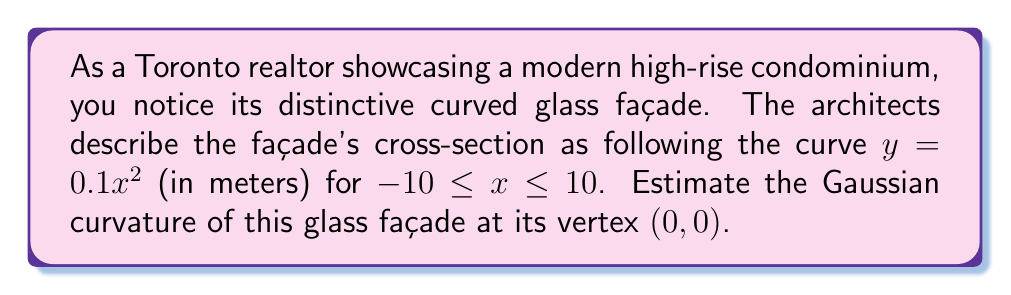Give your solution to this math problem. To estimate the Gaussian curvature of the curved glass façade, we'll follow these steps:

1) The curve is given by $y = 0.1x^2$ in the xz-plane. We can represent this as a surface by extending it along the y-axis:

   $f(x,y) = (x, y, 0.1x^2)$

2) The Gaussian curvature (K) at a point on a surface is the product of the principal curvatures. For a surface of the form $z = g(x)$, the Gaussian curvature at (x, 0) is given by:

   $$K = \frac{g''(x)}{(1 + (g'(x))^2)^2}$$

3) In our case, $g(x) = 0.1x^2$. Let's calculate $g'(x)$ and $g''(x)$:

   $g'(x) = 0.2x$
   $g''(x) = 0.2$

4) We're interested in the curvature at the vertex (0, 0). At x = 0:

   $g'(0) = 0$
   $g''(0) = 0.2$

5) Substituting these values into the Gaussian curvature formula:

   $$K = \frac{0.2}{(1 + 0^2)^2} = 0.2 \text{ m}^{-2}$$

Therefore, the estimated Gaussian curvature of the glass façade at its vertex is 0.2 m^-2.
Answer: $0.2 \text{ m}^{-2}$ 